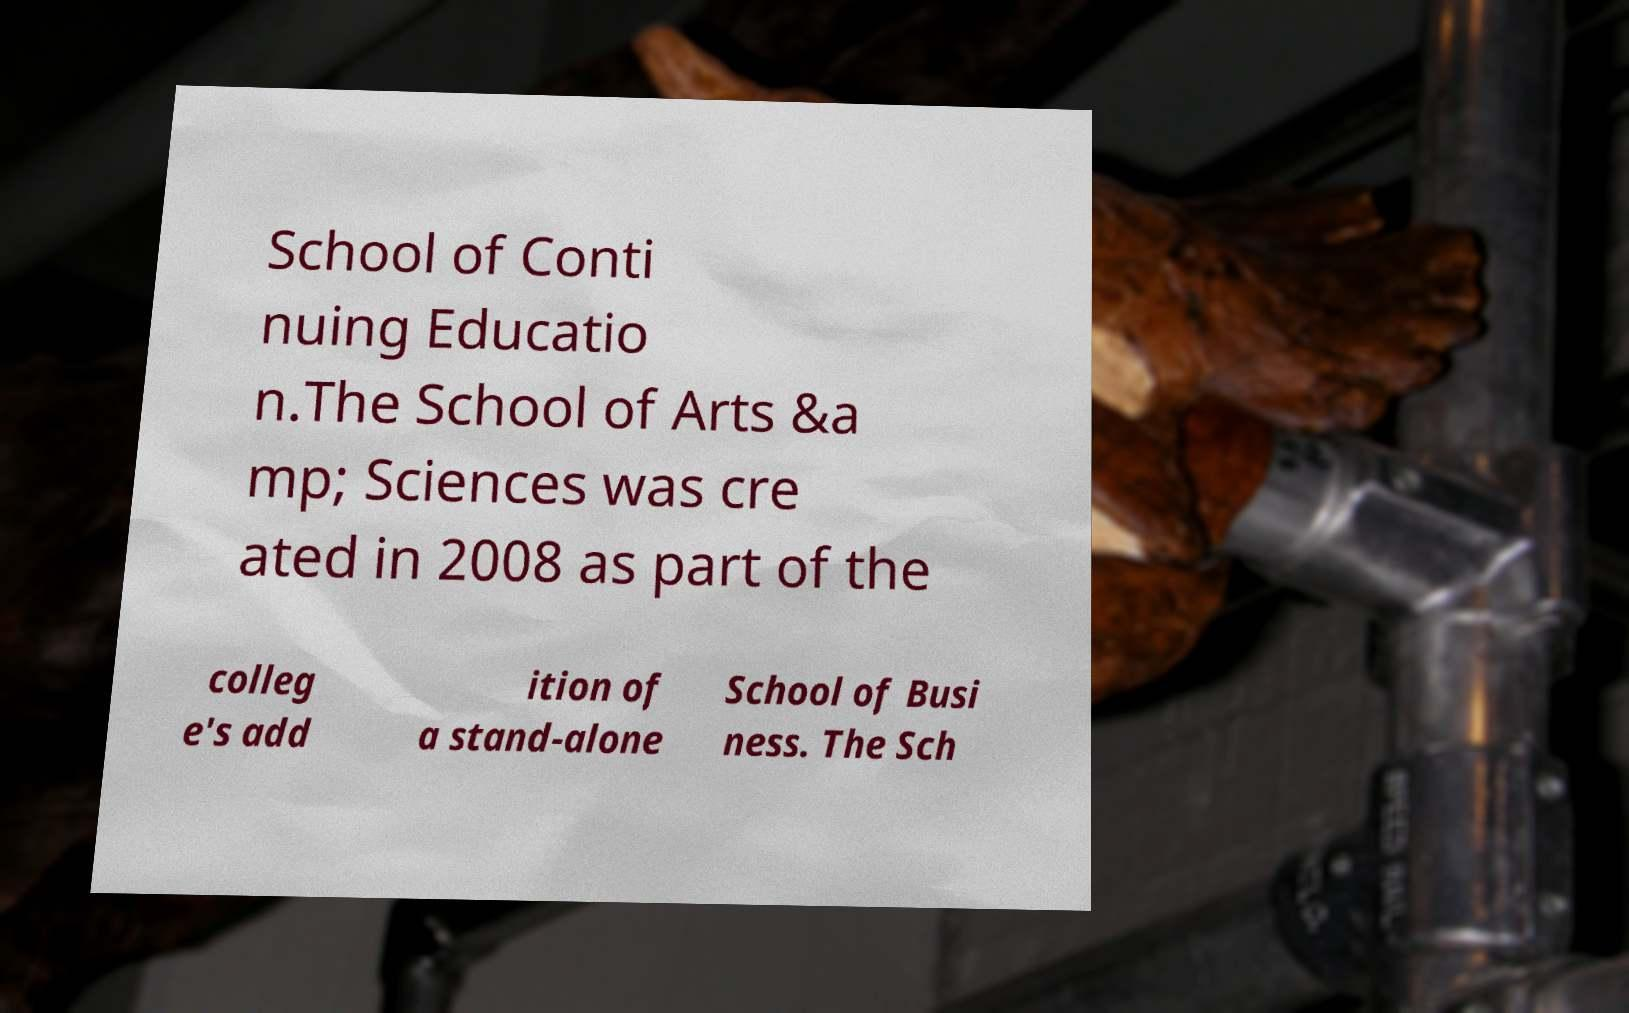Could you extract and type out the text from this image? School of Conti nuing Educatio n.The School of Arts &a mp; Sciences was cre ated in 2008 as part of the colleg e's add ition of a stand-alone School of Busi ness. The Sch 